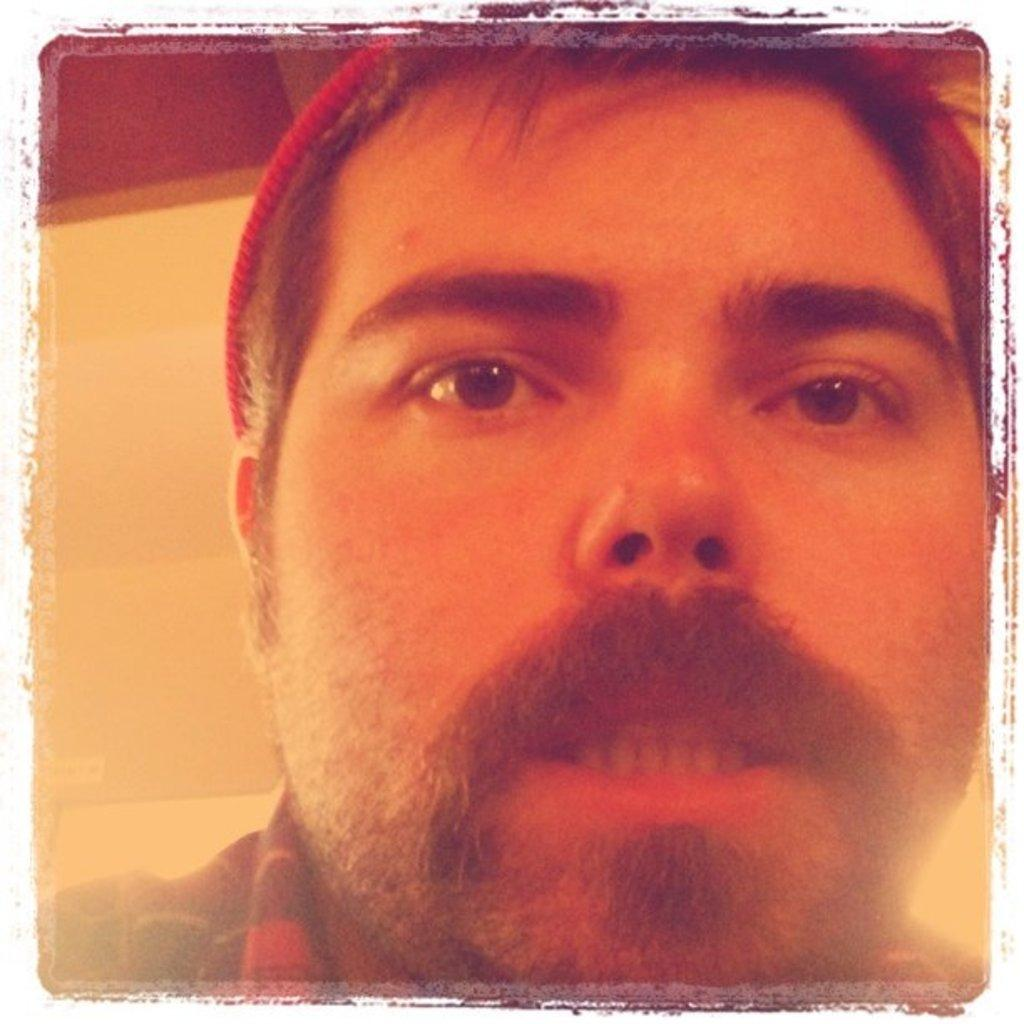What is the main subject of the image? There is a person's face in the image. What can be seen behind the person in the image? There is a wall behind the person in the image. How many balloons are floating above the person's head in the image? There are no balloons present in the image. What type of creature is standing next to the person in the image? There is no creature present in the image; only the person's face and the wall are visible. 